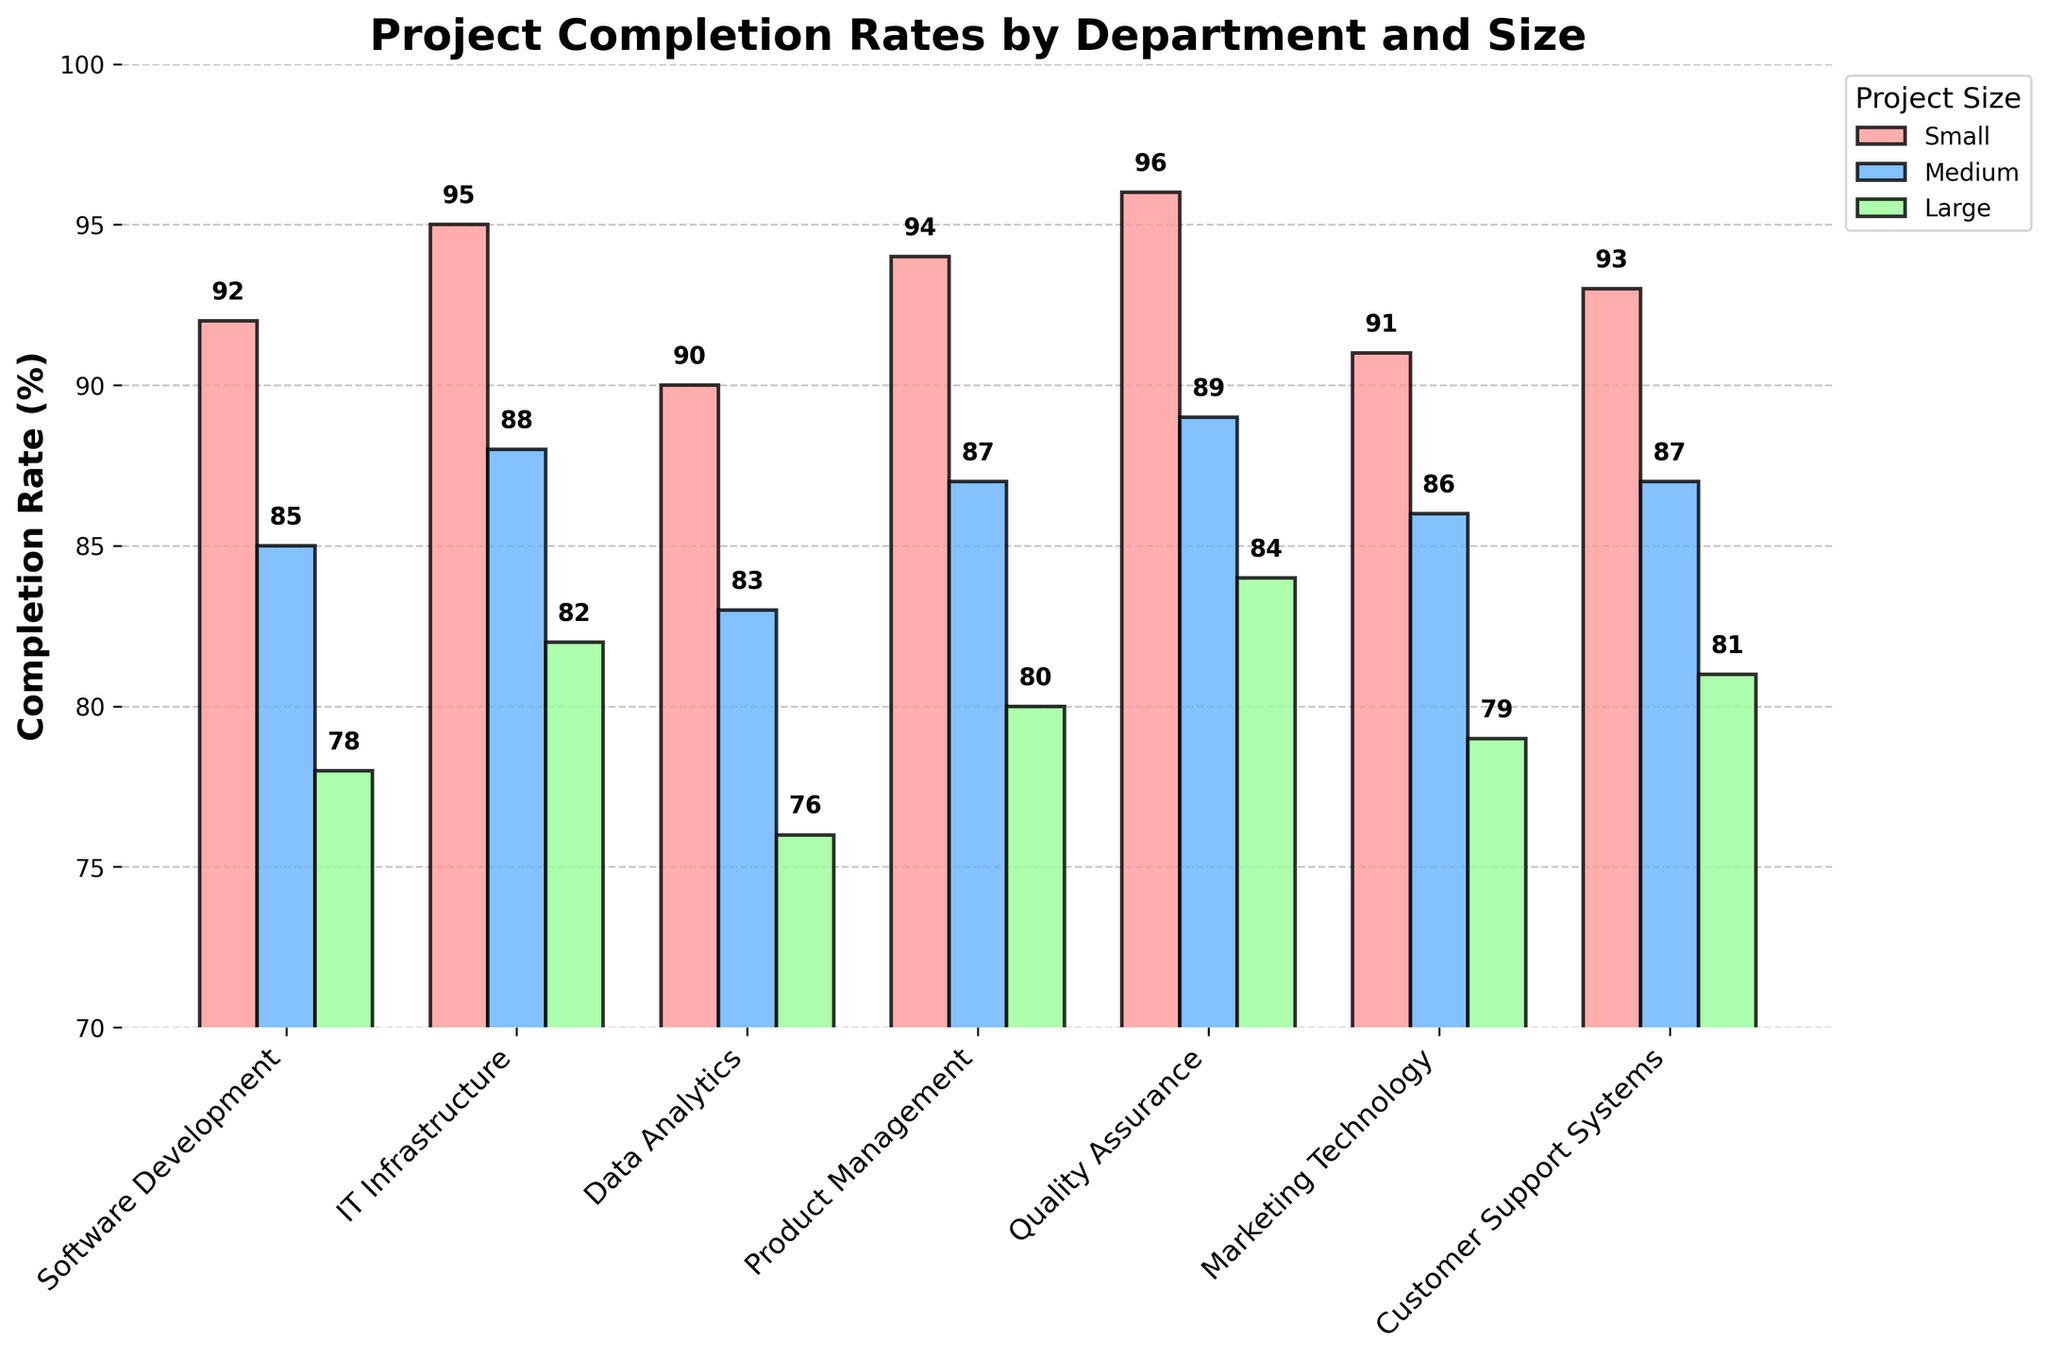Which department has the highest completion rate for small projects? Look for the tallest bar among small projects. Quality Assurance has the highest bar at 96%.
Answer: Quality Assurance Compare the completion rates for medium-sized projects between Software Development and IT Infrastructure. Find and compare the heights of the medium-sized project bars for both departments. Software Development is 85%, and IT Infrastructure is 88%, so IT Infrastructure is higher.
Answer: IT Infrastructure What is the difference in completion rates for large projects between Data Analytics and Customer Support Systems? Look at the heights of the large project bars for both departments. Data Analytics is 76%, and Customer Support Systems is 81%, so the difference is 81% - 76% = 5%.
Answer: 5% Which project size has the lowest average completion rate across all departments? First, calculate the average completion rate for each project size: Small, Medium, and Large. Small: (92+95+90+94+96+91+93)/7 = 93. Mean: (85+88+83+87+89+86+87)/7 = 86. Medium: (78+82+76+80+84+79+81)/7 = 80. The lowest average rate is for Large projects.
Answer: Large Find the difference in completion rate for Product Management in small and large projects. Compare the bars for small and large projects within Product Management. Small is 94%, and Large is 80%, so the difference is 94% - 80% = 14%.
Answer: 14% Which department has the most consistent completion rates across different project sizes? Look at the variation (the difference between the highest and lowest completion rates) within each department. The departments with low variation are more consistent. Quality Assurance has completion rates of 96%, 89%, and 84%, a difference of 12%. This is relatively low.
Answer: Quality Assurance How much higher is the completion rate for small projects in IT Infrastructure compared to medium projects in Marketing Technology? Find the heights of the respective bars: IT Infrastructure Small is 95% and Marketing Technology Medium is 86%. The difference is 95% - 86% = 9%.
Answer: 9% What is the average completion rate for large projects across all departments? Sum the completion rates for large projects in all departments, then divide by the number of departments: (78+82+76+80+84+79+81)/7 = 80.
Answer: 80 Which department shows the greatest decrease in completion rate from small to large projects? Calculate the decrease in completion rate from small to large projects for each department and find the department with the highest decrease. Software Development has a decrease from 92% to 78%, which is 14%. This is the highest decrease.
Answer: Software Development Is the completion rate for medium projects in Data Analytics higher or lower than the completion rate for large projects in Product Management? Compare the heights of the medium project bar for Data Analytics and the large project bar for Product Management. Data Analytics Medium is 83%, and Product Management Large is 80%. So, Data Analytics Medium is higher.
Answer: Higher 